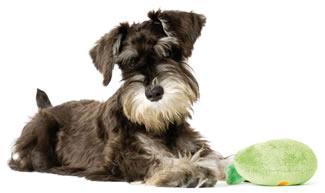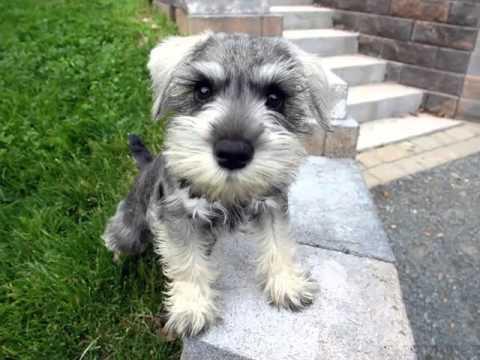The first image is the image on the left, the second image is the image on the right. Given the left and right images, does the statement "The dogs in the images are all looking straight ahead" hold true? Answer yes or no. Yes. 